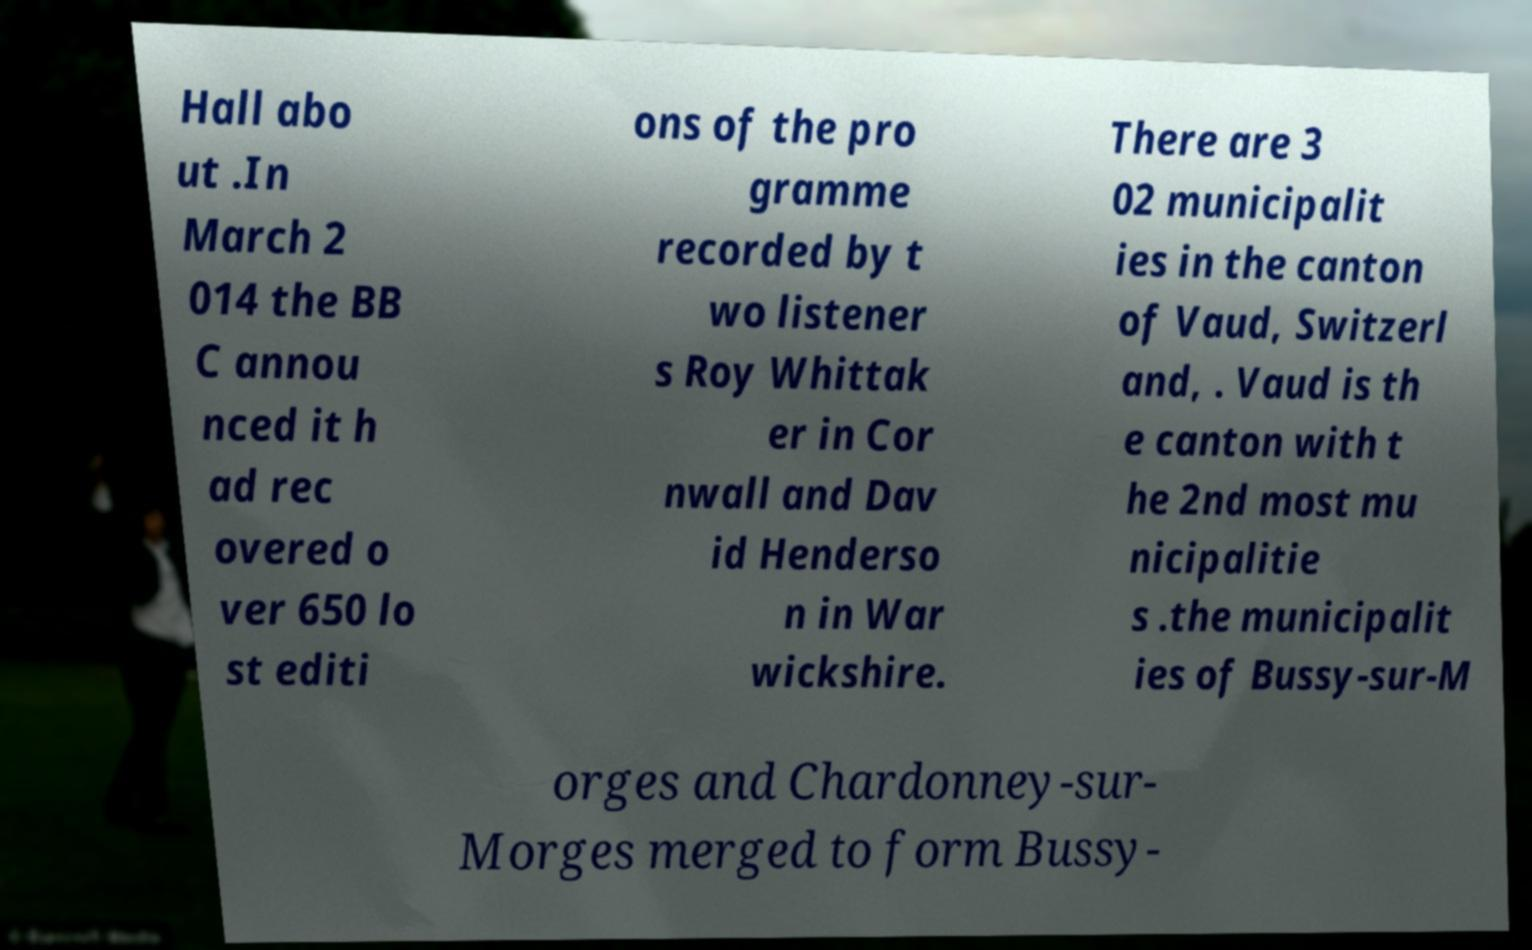Can you read and provide the text displayed in the image?This photo seems to have some interesting text. Can you extract and type it out for me? Hall abo ut .In March 2 014 the BB C annou nced it h ad rec overed o ver 650 lo st editi ons of the pro gramme recorded by t wo listener s Roy Whittak er in Cor nwall and Dav id Henderso n in War wickshire. There are 3 02 municipalit ies in the canton of Vaud, Switzerl and, . Vaud is th e canton with t he 2nd most mu nicipalitie s .the municipalit ies of Bussy-sur-M orges and Chardonney-sur- Morges merged to form Bussy- 